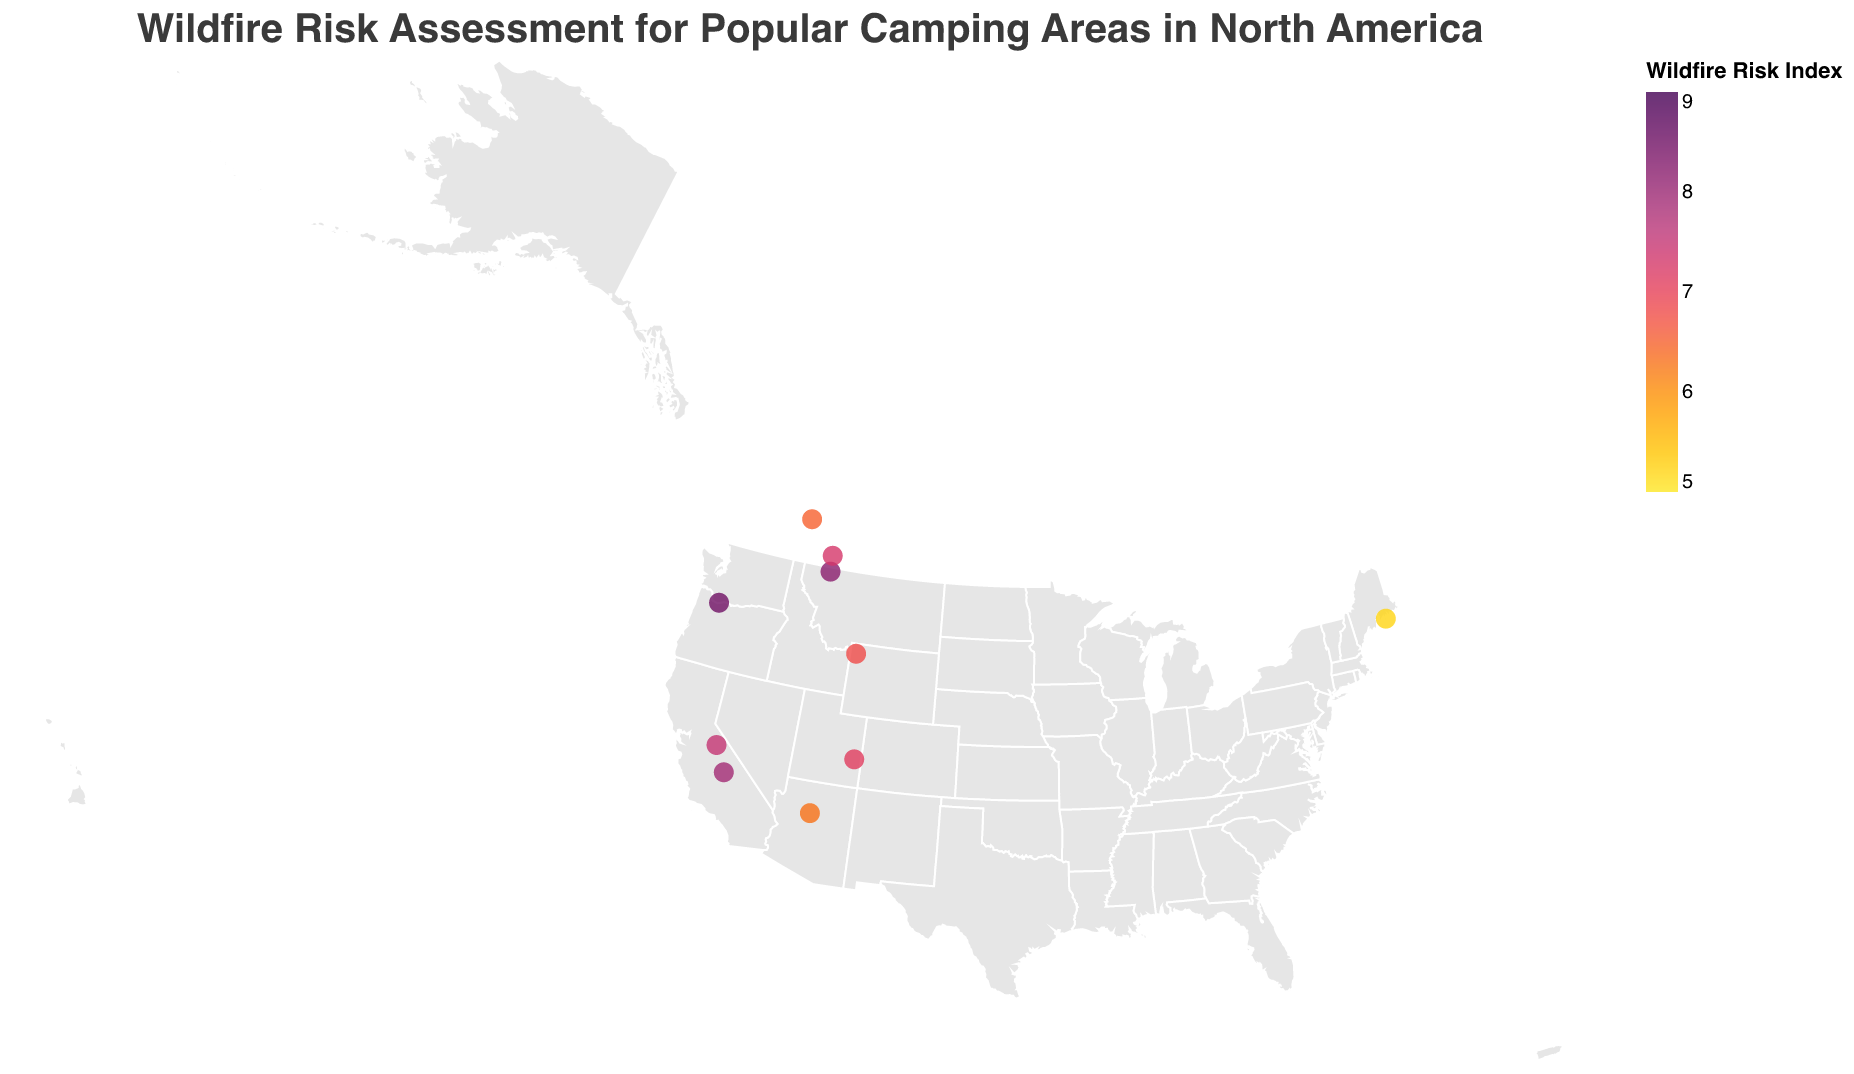What is the wildland park with the highest wildfire risk? Locate the circle with the highest wildfire risk index. The Columbia River Gorge has an index of 8.5, which is the highest in the figure.
Answer: Columbia River Gorge Which camping area had the most recent incident? Identify the camping area with the latest "Last Incident" year. The Arches National Park (Devils Garden Campground) had an incident in 2021, which is the most recent.
Answer: Arches National Park, 2021 What is the average wildfire risk index for the campgrounds? Add all wildfire risk indices: 8.2 + 7.9 + 7.5 + 6.8 + 6.5 + 7.1 + 6.3 + 8.5 + 5.2 + 7.3 = 71.3. There are 10 campgrounds, so the average is 71.3 / 10.
Answer: 7.13 Which campground had the last incident in Yellowstone National Park? Look for Yellowstone National Park and check the associated campground and last incident year. The Madison Campground had its last incident in 2016.
Answer: Madison Campground, 2016 Which location has the lowest wildfire risk index and what is the value? Find the circle with the lowest value in the wildfire risk index color scale. Acadia National Park has the lowest index, which is 5.2.
Answer: Acadia National Park, 5.2 Compare the wildfire risk between Yosemite National Park and Glacier National Park. Which one is higher? Refer to the wildfire risk indices for each location. Yosemite National Park has a risk index of 7.5, and Glacier National Park has a risk index of 8.2. Thus, Glacier National Park has a higher risk.
Answer: Glacier National Park What are the color ranges used in the plot representing the wildfire risk index? The colors range from light yellow to dark purple to represent increasing risk. The specific colors are yellow for low risk and dark purple for high risk.
Answer: Yellow to dark purple How many campgrounds have had their last incident after 2018? Check the "Last Incident" field for all campgrounds and count those after 2018. Only one campground, the Devils Garden Campground in Arches National Park, had an incident after 2018.
Answer: One In which national park is the Two Jack Lakeside campground located, and what is its wildfire risk index? Find the relevant data point for Two Jack Lakeside. It is located in Banff National Park and has a wildfire risk index of 6.5.
Answer: Banff National Park, 6.5 What is the median wildfire risk index for all campgrounds? Arrange the wildfire risk indices in ascending order: 5.2, 6.3, 6.5, 6.8, 7.1, 7.3, 7.5, 7.9, 8.2, 8.5. The median value is the average of the 5th and 6th indices (7.1 and 7.3). (7.1 + 7.3) / 2 = 7.2.
Answer: 7.2 